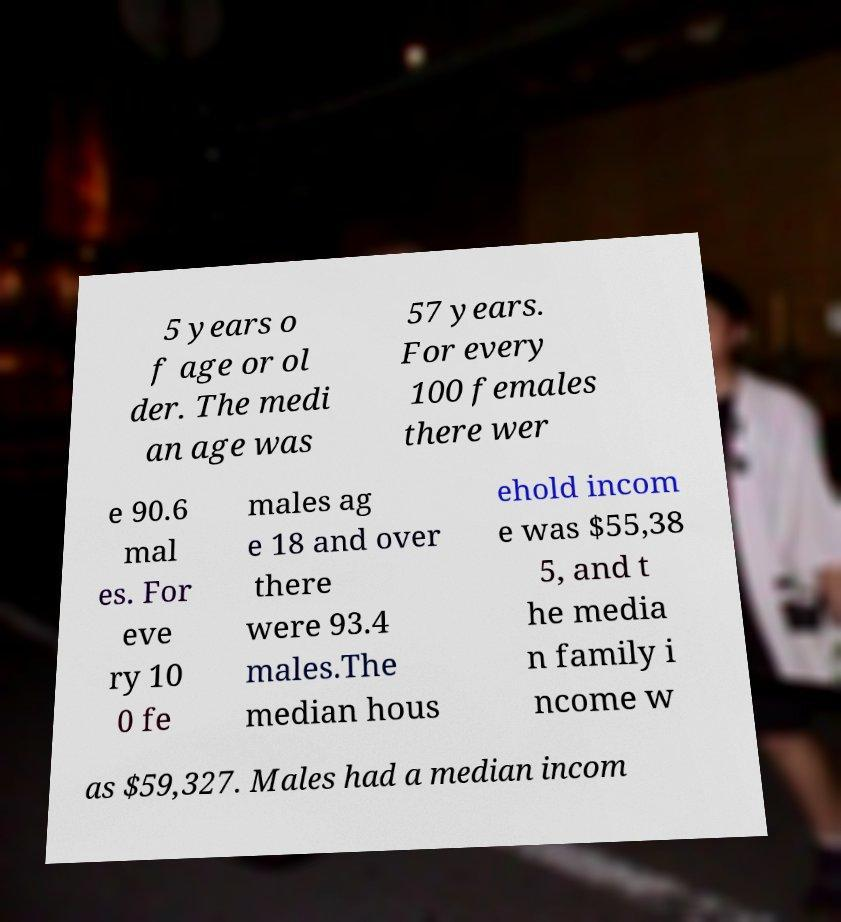Can you accurately transcribe the text from the provided image for me? 5 years o f age or ol der. The medi an age was 57 years. For every 100 females there wer e 90.6 mal es. For eve ry 10 0 fe males ag e 18 and over there were 93.4 males.The median hous ehold incom e was $55,38 5, and t he media n family i ncome w as $59,327. Males had a median incom 